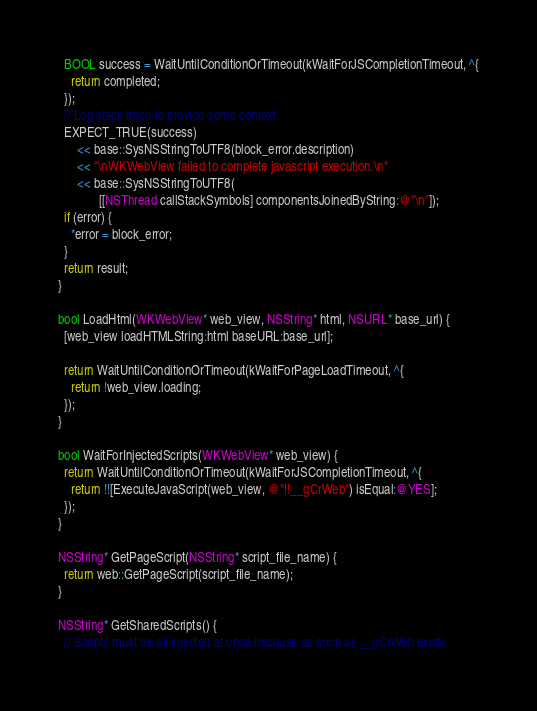<code> <loc_0><loc_0><loc_500><loc_500><_ObjectiveC_>  BOOL success = WaitUntilConditionOrTimeout(kWaitForJSCompletionTimeout, ^{
    return completed;
  });
  // Log stack trace to provide some context.
  EXPECT_TRUE(success)
      << base::SysNSStringToUTF8(block_error.description)
      << "\nWKWebView failed to complete javascript execution.\n"
      << base::SysNSStringToUTF8(
             [[NSThread callStackSymbols] componentsJoinedByString:@"\n"]);
  if (error) {
    *error = block_error;
  }
  return result;
}

bool LoadHtml(WKWebView* web_view, NSString* html, NSURL* base_url) {
  [web_view loadHTMLString:html baseURL:base_url];

  return WaitUntilConditionOrTimeout(kWaitForPageLoadTimeout, ^{
    return !web_view.loading;
  });
}

bool WaitForInjectedScripts(WKWebView* web_view) {
  return WaitUntilConditionOrTimeout(kWaitForJSCompletionTimeout, ^{
    return !![ExecuteJavaScript(web_view, @"!!__gCrWeb") isEqual:@YES];
  });
}

NSString* GetPageScript(NSString* script_file_name) {
  return web::GetPageScript(script_file_name);
}

NSString* GetSharedScripts() {
  // Scripts must be all injected at once because as soon as __gCrWeb exists,</code> 